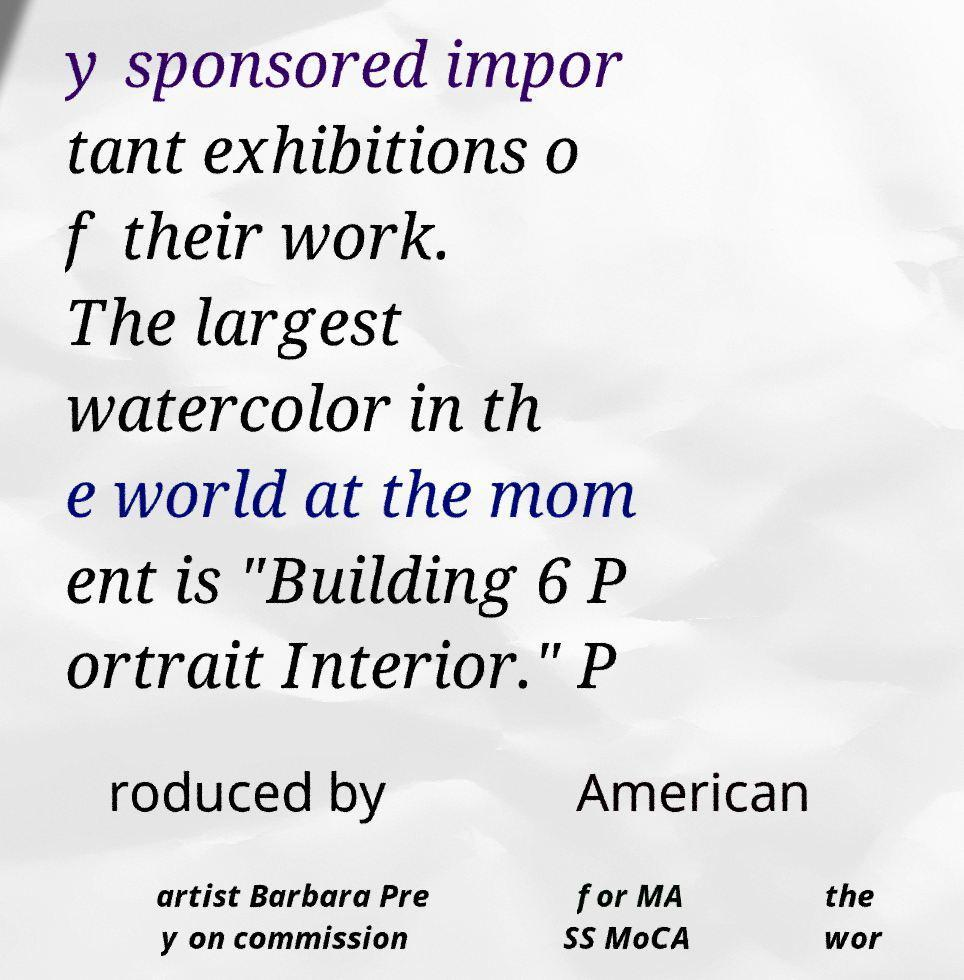For documentation purposes, I need the text within this image transcribed. Could you provide that? y sponsored impor tant exhibitions o f their work. The largest watercolor in th e world at the mom ent is "Building 6 P ortrait Interior." P roduced by American artist Barbara Pre y on commission for MA SS MoCA the wor 